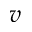<formula> <loc_0><loc_0><loc_500><loc_500>v</formula> 